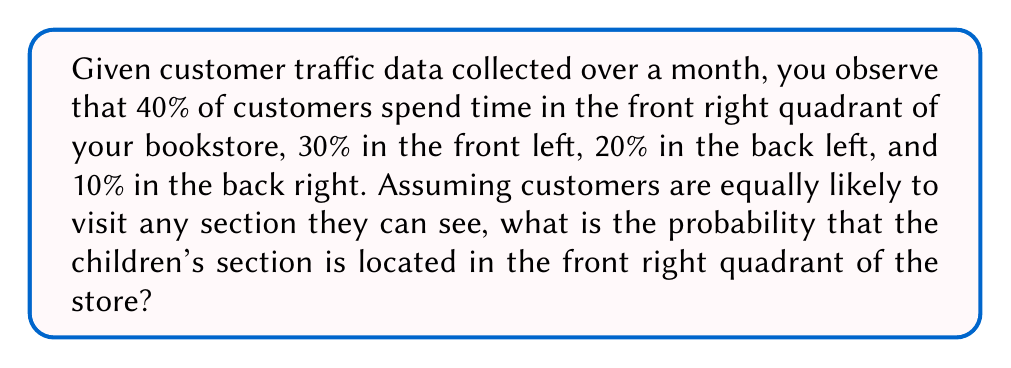Could you help me with this problem? Let's approach this step-by-step:

1) First, we need to understand what the data tells us. The traffic pattern suggests that the most popular area is the front right quadrant, followed by the front left, then back left, and finally back right.

2) We know that children's sections in bookstores are typically popular and attract a lot of traffic. Given this, it's more likely to be in a high-traffic area.

3) Let's define our events:
   A: Children's section is in the front right quadrant
   B: Observed traffic pattern

4) We want to find P(A|B), the probability of A given B.

5) We can use Bayes' theorem:

   $$P(A|B) = \frac{P(B|A) \cdot P(A)}{P(B)}$$

6) Let's break this down:
   - P(A) is the prior probability. Without any information, we might assume it's equally likely to be in any quadrant, so P(A) = 1/4.
   - P(B|A) is the likelihood of observing this traffic pattern if the children's section is in the front right. Given that children's sections attract high traffic, this is likely to be high, let's estimate it at 0.8.
   - P(B) is the probability of observing this traffic pattern in general. We can calculate this using the law of total probability:

     $$P(B) = P(B|A)P(A) + P(B|A^c)P(A^c)$$

     where $A^c$ is the event that the children's section is not in the front right.

7) We need to estimate P(B|A^c). If the children's section is not in the front right, the probability of observing this exact traffic pattern would be lower, let's estimate it at 0.3.

8) Now we can calculate P(B):

   $$P(B) = 0.8 \cdot 0.25 + 0.3 \cdot 0.75 = 0.2 + 0.225 = 0.425$$

9) Putting it all together:

   $$P(A|B) = \frac{0.8 \cdot 0.25}{0.425} \approx 0.4706$$
Answer: 0.4706 